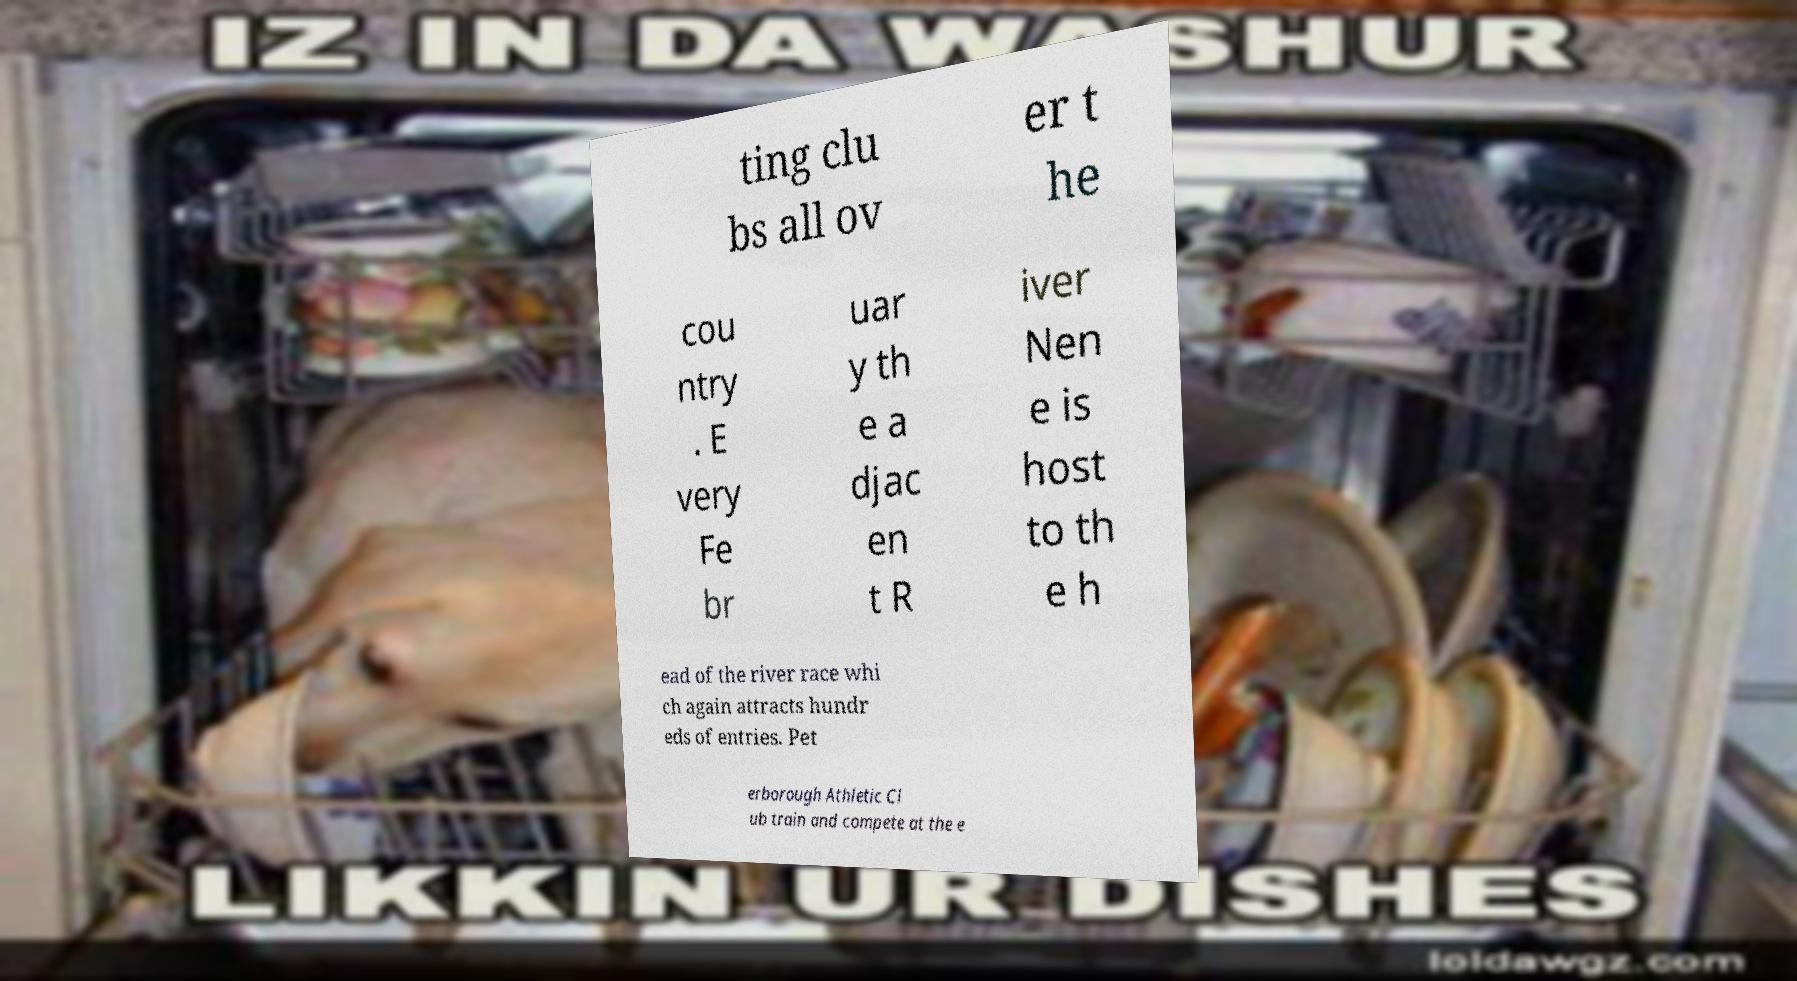Please read and relay the text visible in this image. What does it say? ting clu bs all ov er t he cou ntry . E very Fe br uar y th e a djac en t R iver Nen e is host to th e h ead of the river race whi ch again attracts hundr eds of entries. Pet erborough Athletic Cl ub train and compete at the e 